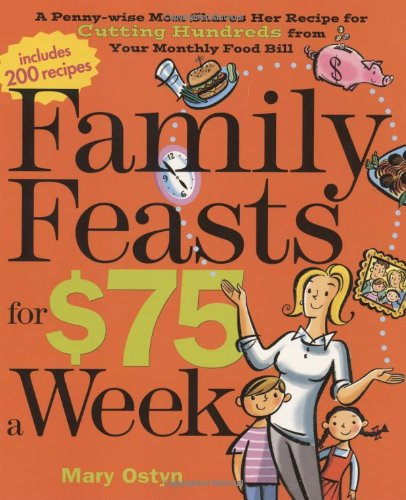Who is the author of this book?
Answer the question using a single word or phrase. Mary Ostyn What is the title of this book? Family Feasts for $75 a Week: A Penny-wise Mom Shares Her Recipe for Cutting Hundreds from Your Monthly Food Bill What type of book is this? Cookbooks, Food & Wine Is this a recipe book? Yes Is this a crafts or hobbies related book? No 